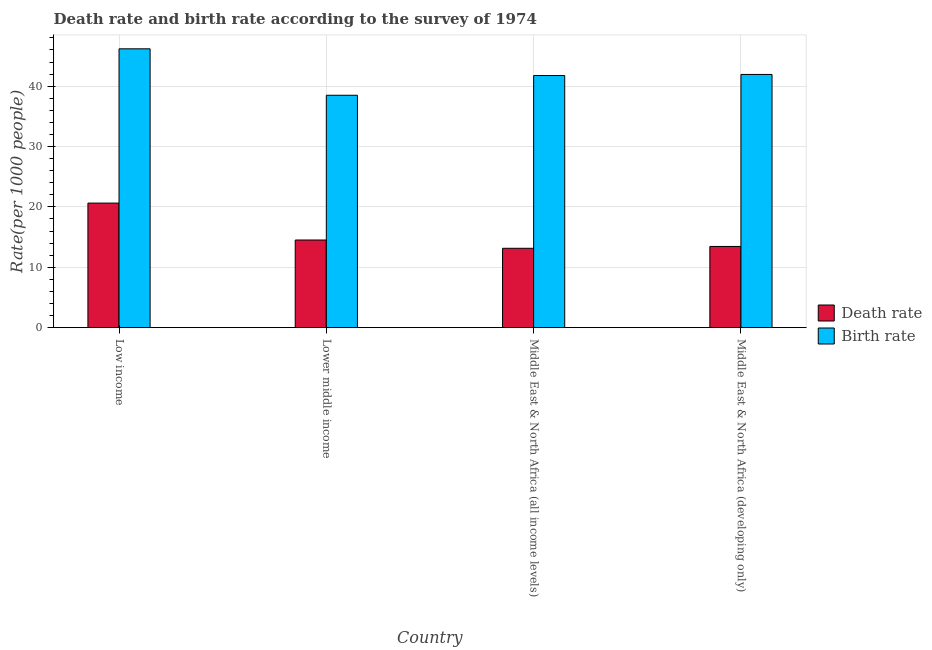How many different coloured bars are there?
Offer a terse response. 2. How many groups of bars are there?
Your answer should be compact. 4. How many bars are there on the 2nd tick from the right?
Make the answer very short. 2. What is the label of the 3rd group of bars from the left?
Offer a terse response. Middle East & North Africa (all income levels). What is the death rate in Middle East & North Africa (all income levels)?
Your response must be concise. 13.15. Across all countries, what is the maximum death rate?
Make the answer very short. 20.63. Across all countries, what is the minimum birth rate?
Offer a terse response. 38.49. In which country was the death rate minimum?
Give a very brief answer. Middle East & North Africa (all income levels). What is the total death rate in the graph?
Your answer should be very brief. 61.75. What is the difference between the death rate in Low income and that in Lower middle income?
Your response must be concise. 6.11. What is the difference between the birth rate in Lower middle income and the death rate in Low income?
Offer a very short reply. 17.86. What is the average birth rate per country?
Provide a short and direct response. 42.09. What is the difference between the birth rate and death rate in Middle East & North Africa (all income levels)?
Give a very brief answer. 28.61. In how many countries, is the birth rate greater than 20 ?
Your answer should be compact. 4. What is the ratio of the birth rate in Low income to that in Middle East & North Africa (developing only)?
Offer a very short reply. 1.1. Is the death rate in Lower middle income less than that in Middle East & North Africa (developing only)?
Provide a short and direct response. No. Is the difference between the death rate in Low income and Lower middle income greater than the difference between the birth rate in Low income and Lower middle income?
Keep it short and to the point. No. What is the difference between the highest and the second highest birth rate?
Give a very brief answer. 4.25. What is the difference between the highest and the lowest birth rate?
Your response must be concise. 7.69. What does the 1st bar from the left in Low income represents?
Give a very brief answer. Death rate. What does the 2nd bar from the right in Middle East & North Africa (all income levels) represents?
Make the answer very short. Death rate. How many countries are there in the graph?
Your answer should be compact. 4. What is the difference between two consecutive major ticks on the Y-axis?
Keep it short and to the point. 10. Are the values on the major ticks of Y-axis written in scientific E-notation?
Your response must be concise. No. Does the graph contain any zero values?
Provide a short and direct response. No. How many legend labels are there?
Give a very brief answer. 2. How are the legend labels stacked?
Make the answer very short. Vertical. What is the title of the graph?
Provide a short and direct response. Death rate and birth rate according to the survey of 1974. What is the label or title of the X-axis?
Make the answer very short. Country. What is the label or title of the Y-axis?
Offer a terse response. Rate(per 1000 people). What is the Rate(per 1000 people) in Death rate in Low income?
Offer a very short reply. 20.63. What is the Rate(per 1000 people) in Birth rate in Low income?
Your response must be concise. 46.19. What is the Rate(per 1000 people) in Death rate in Lower middle income?
Give a very brief answer. 14.52. What is the Rate(per 1000 people) of Birth rate in Lower middle income?
Make the answer very short. 38.49. What is the Rate(per 1000 people) of Death rate in Middle East & North Africa (all income levels)?
Your answer should be very brief. 13.15. What is the Rate(per 1000 people) in Birth rate in Middle East & North Africa (all income levels)?
Your answer should be very brief. 41.76. What is the Rate(per 1000 people) of Death rate in Middle East & North Africa (developing only)?
Give a very brief answer. 13.45. What is the Rate(per 1000 people) in Birth rate in Middle East & North Africa (developing only)?
Your answer should be compact. 41.94. Across all countries, what is the maximum Rate(per 1000 people) in Death rate?
Make the answer very short. 20.63. Across all countries, what is the maximum Rate(per 1000 people) of Birth rate?
Provide a succinct answer. 46.19. Across all countries, what is the minimum Rate(per 1000 people) of Death rate?
Ensure brevity in your answer.  13.15. Across all countries, what is the minimum Rate(per 1000 people) in Birth rate?
Provide a short and direct response. 38.49. What is the total Rate(per 1000 people) in Death rate in the graph?
Your answer should be very brief. 61.75. What is the total Rate(per 1000 people) of Birth rate in the graph?
Give a very brief answer. 168.38. What is the difference between the Rate(per 1000 people) of Death rate in Low income and that in Lower middle income?
Your answer should be very brief. 6.11. What is the difference between the Rate(per 1000 people) in Birth rate in Low income and that in Lower middle income?
Offer a very short reply. 7.69. What is the difference between the Rate(per 1000 people) in Death rate in Low income and that in Middle East & North Africa (all income levels)?
Provide a succinct answer. 7.49. What is the difference between the Rate(per 1000 people) of Birth rate in Low income and that in Middle East & North Africa (all income levels)?
Give a very brief answer. 4.43. What is the difference between the Rate(per 1000 people) of Death rate in Low income and that in Middle East & North Africa (developing only)?
Your answer should be compact. 7.18. What is the difference between the Rate(per 1000 people) in Birth rate in Low income and that in Middle East & North Africa (developing only)?
Your response must be concise. 4.25. What is the difference between the Rate(per 1000 people) of Death rate in Lower middle income and that in Middle East & North Africa (all income levels)?
Give a very brief answer. 1.37. What is the difference between the Rate(per 1000 people) in Birth rate in Lower middle income and that in Middle East & North Africa (all income levels)?
Your answer should be compact. -3.27. What is the difference between the Rate(per 1000 people) of Death rate in Lower middle income and that in Middle East & North Africa (developing only)?
Your answer should be compact. 1.07. What is the difference between the Rate(per 1000 people) of Birth rate in Lower middle income and that in Middle East & North Africa (developing only)?
Provide a short and direct response. -3.45. What is the difference between the Rate(per 1000 people) in Death rate in Middle East & North Africa (all income levels) and that in Middle East & North Africa (developing only)?
Make the answer very short. -0.31. What is the difference between the Rate(per 1000 people) of Birth rate in Middle East & North Africa (all income levels) and that in Middle East & North Africa (developing only)?
Your answer should be very brief. -0.18. What is the difference between the Rate(per 1000 people) in Death rate in Low income and the Rate(per 1000 people) in Birth rate in Lower middle income?
Ensure brevity in your answer.  -17.86. What is the difference between the Rate(per 1000 people) of Death rate in Low income and the Rate(per 1000 people) of Birth rate in Middle East & North Africa (all income levels)?
Give a very brief answer. -21.13. What is the difference between the Rate(per 1000 people) of Death rate in Low income and the Rate(per 1000 people) of Birth rate in Middle East & North Africa (developing only)?
Provide a short and direct response. -21.31. What is the difference between the Rate(per 1000 people) of Death rate in Lower middle income and the Rate(per 1000 people) of Birth rate in Middle East & North Africa (all income levels)?
Offer a very short reply. -27.24. What is the difference between the Rate(per 1000 people) of Death rate in Lower middle income and the Rate(per 1000 people) of Birth rate in Middle East & North Africa (developing only)?
Provide a short and direct response. -27.42. What is the difference between the Rate(per 1000 people) in Death rate in Middle East & North Africa (all income levels) and the Rate(per 1000 people) in Birth rate in Middle East & North Africa (developing only)?
Offer a very short reply. -28.79. What is the average Rate(per 1000 people) in Death rate per country?
Make the answer very short. 15.44. What is the average Rate(per 1000 people) in Birth rate per country?
Offer a terse response. 42.09. What is the difference between the Rate(per 1000 people) in Death rate and Rate(per 1000 people) in Birth rate in Low income?
Offer a terse response. -25.55. What is the difference between the Rate(per 1000 people) of Death rate and Rate(per 1000 people) of Birth rate in Lower middle income?
Your answer should be compact. -23.97. What is the difference between the Rate(per 1000 people) in Death rate and Rate(per 1000 people) in Birth rate in Middle East & North Africa (all income levels)?
Ensure brevity in your answer.  -28.61. What is the difference between the Rate(per 1000 people) of Death rate and Rate(per 1000 people) of Birth rate in Middle East & North Africa (developing only)?
Make the answer very short. -28.49. What is the ratio of the Rate(per 1000 people) of Death rate in Low income to that in Lower middle income?
Offer a terse response. 1.42. What is the ratio of the Rate(per 1000 people) in Birth rate in Low income to that in Lower middle income?
Your answer should be compact. 1.2. What is the ratio of the Rate(per 1000 people) of Death rate in Low income to that in Middle East & North Africa (all income levels)?
Your response must be concise. 1.57. What is the ratio of the Rate(per 1000 people) of Birth rate in Low income to that in Middle East & North Africa (all income levels)?
Provide a short and direct response. 1.11. What is the ratio of the Rate(per 1000 people) in Death rate in Low income to that in Middle East & North Africa (developing only)?
Give a very brief answer. 1.53. What is the ratio of the Rate(per 1000 people) of Birth rate in Low income to that in Middle East & North Africa (developing only)?
Offer a very short reply. 1.1. What is the ratio of the Rate(per 1000 people) of Death rate in Lower middle income to that in Middle East & North Africa (all income levels)?
Your answer should be compact. 1.1. What is the ratio of the Rate(per 1000 people) of Birth rate in Lower middle income to that in Middle East & North Africa (all income levels)?
Your answer should be compact. 0.92. What is the ratio of the Rate(per 1000 people) of Death rate in Lower middle income to that in Middle East & North Africa (developing only)?
Offer a very short reply. 1.08. What is the ratio of the Rate(per 1000 people) in Birth rate in Lower middle income to that in Middle East & North Africa (developing only)?
Your answer should be compact. 0.92. What is the ratio of the Rate(per 1000 people) in Death rate in Middle East & North Africa (all income levels) to that in Middle East & North Africa (developing only)?
Provide a short and direct response. 0.98. What is the ratio of the Rate(per 1000 people) in Birth rate in Middle East & North Africa (all income levels) to that in Middle East & North Africa (developing only)?
Provide a succinct answer. 1. What is the difference between the highest and the second highest Rate(per 1000 people) of Death rate?
Keep it short and to the point. 6.11. What is the difference between the highest and the second highest Rate(per 1000 people) in Birth rate?
Provide a succinct answer. 4.25. What is the difference between the highest and the lowest Rate(per 1000 people) in Death rate?
Make the answer very short. 7.49. What is the difference between the highest and the lowest Rate(per 1000 people) of Birth rate?
Keep it short and to the point. 7.69. 